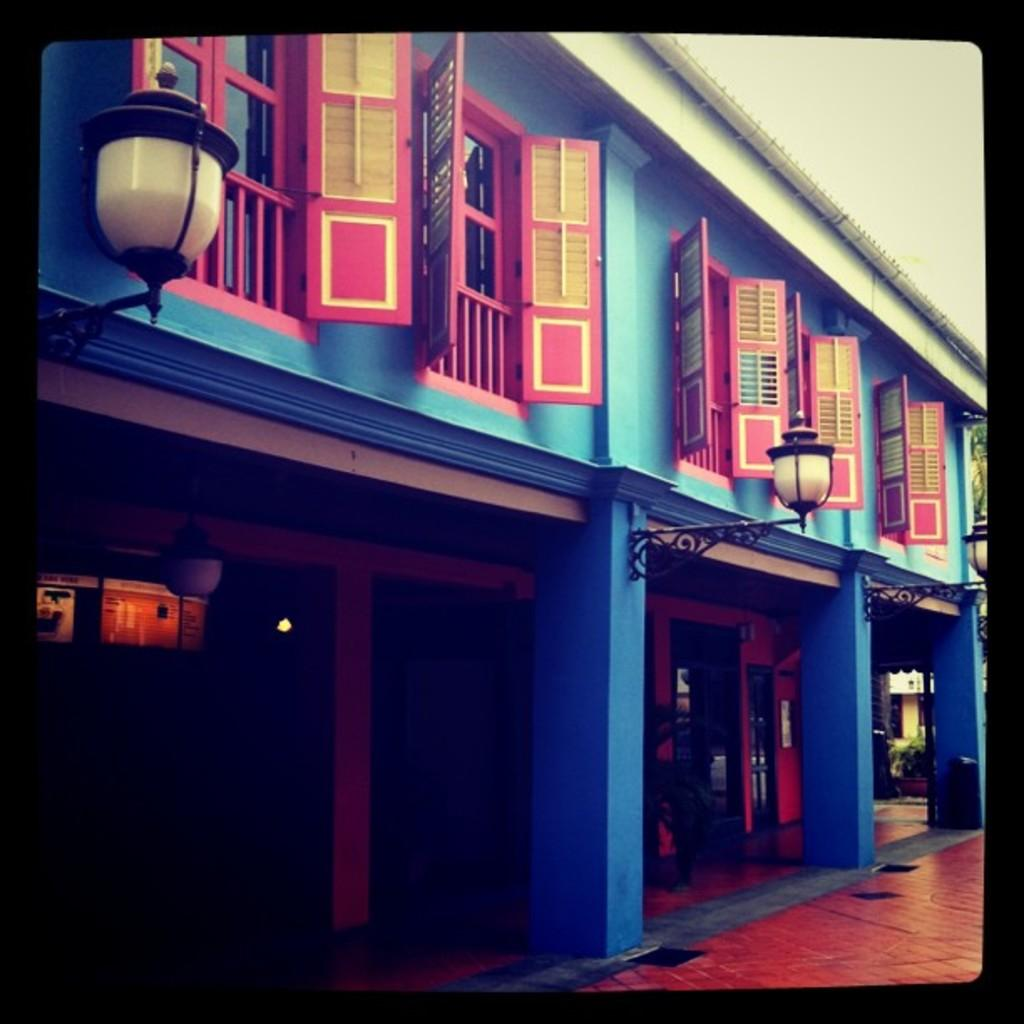What architectural features can be seen in the image? There are windows, lights, and pillars visible in the image. What type of structure is present in the image? There is a building in the image. What is visible in the background of the image? The sky is visible in the background of the image. Can you give an example of a banana in the image? There is no banana present in the image. How does the building blow in the wind in the image? The building does not blow in the wind in the image; it is stationary. 